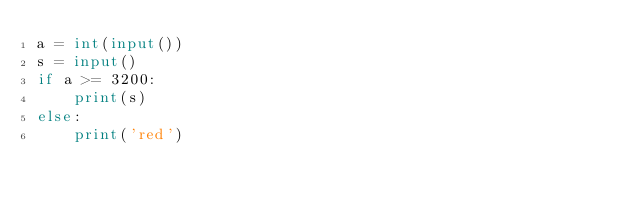<code> <loc_0><loc_0><loc_500><loc_500><_Python_>a = int(input())
s = input()
if a >= 3200:
    print(s)
else:
    print('red')</code> 